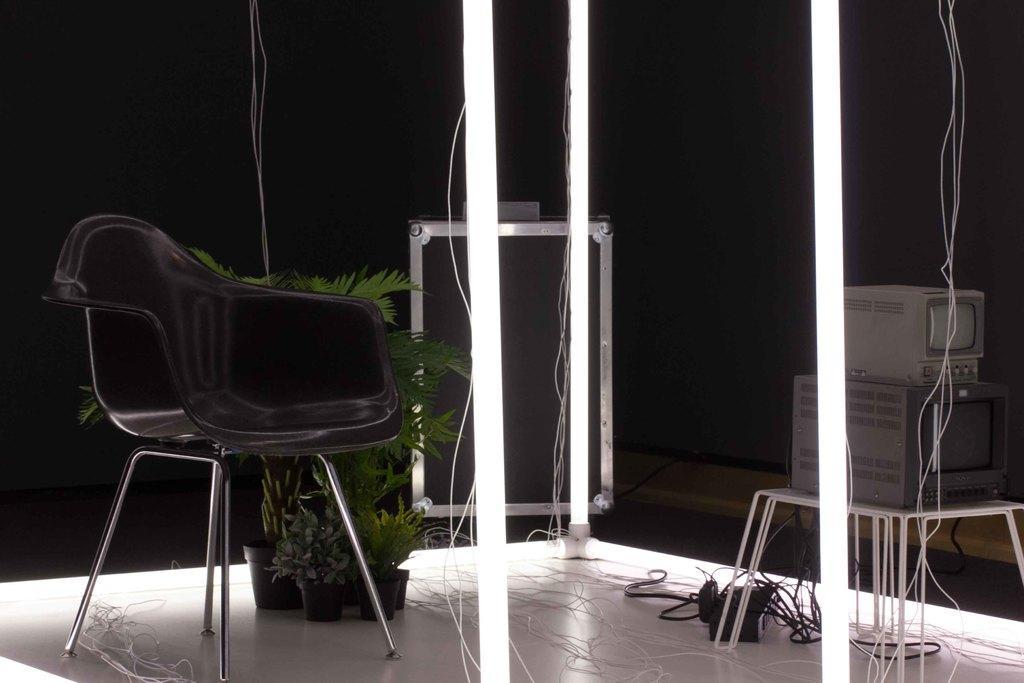How would you summarize this image in a sentence or two? In the left side it is a chair which is in black color and these are the plants. 